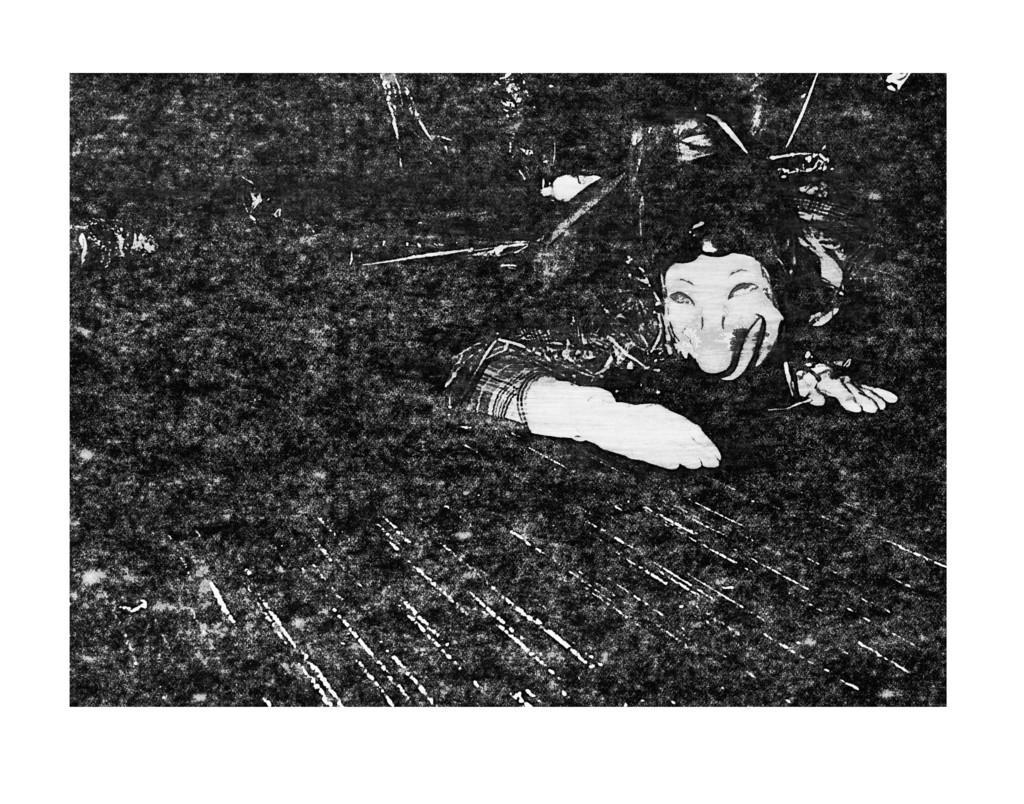Could you give a brief overview of what you see in this image? This image is very dark and we can see a person. 